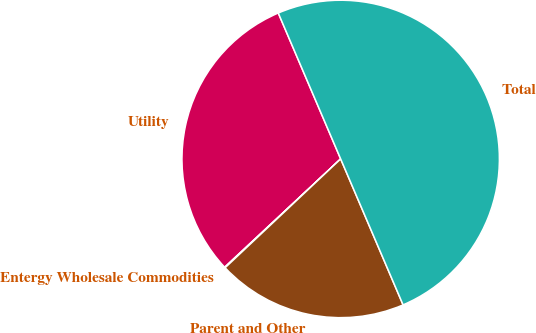Convert chart. <chart><loc_0><loc_0><loc_500><loc_500><pie_chart><fcel>Utility<fcel>Entergy Wholesale Commodities<fcel>Parent and Other<fcel>Total<nl><fcel>30.52%<fcel>0.07%<fcel>19.41%<fcel>50.0%<nl></chart> 